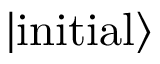Convert formula to latex. <formula><loc_0><loc_0><loc_500><loc_500>| i n i t i a l \rangle</formula> 